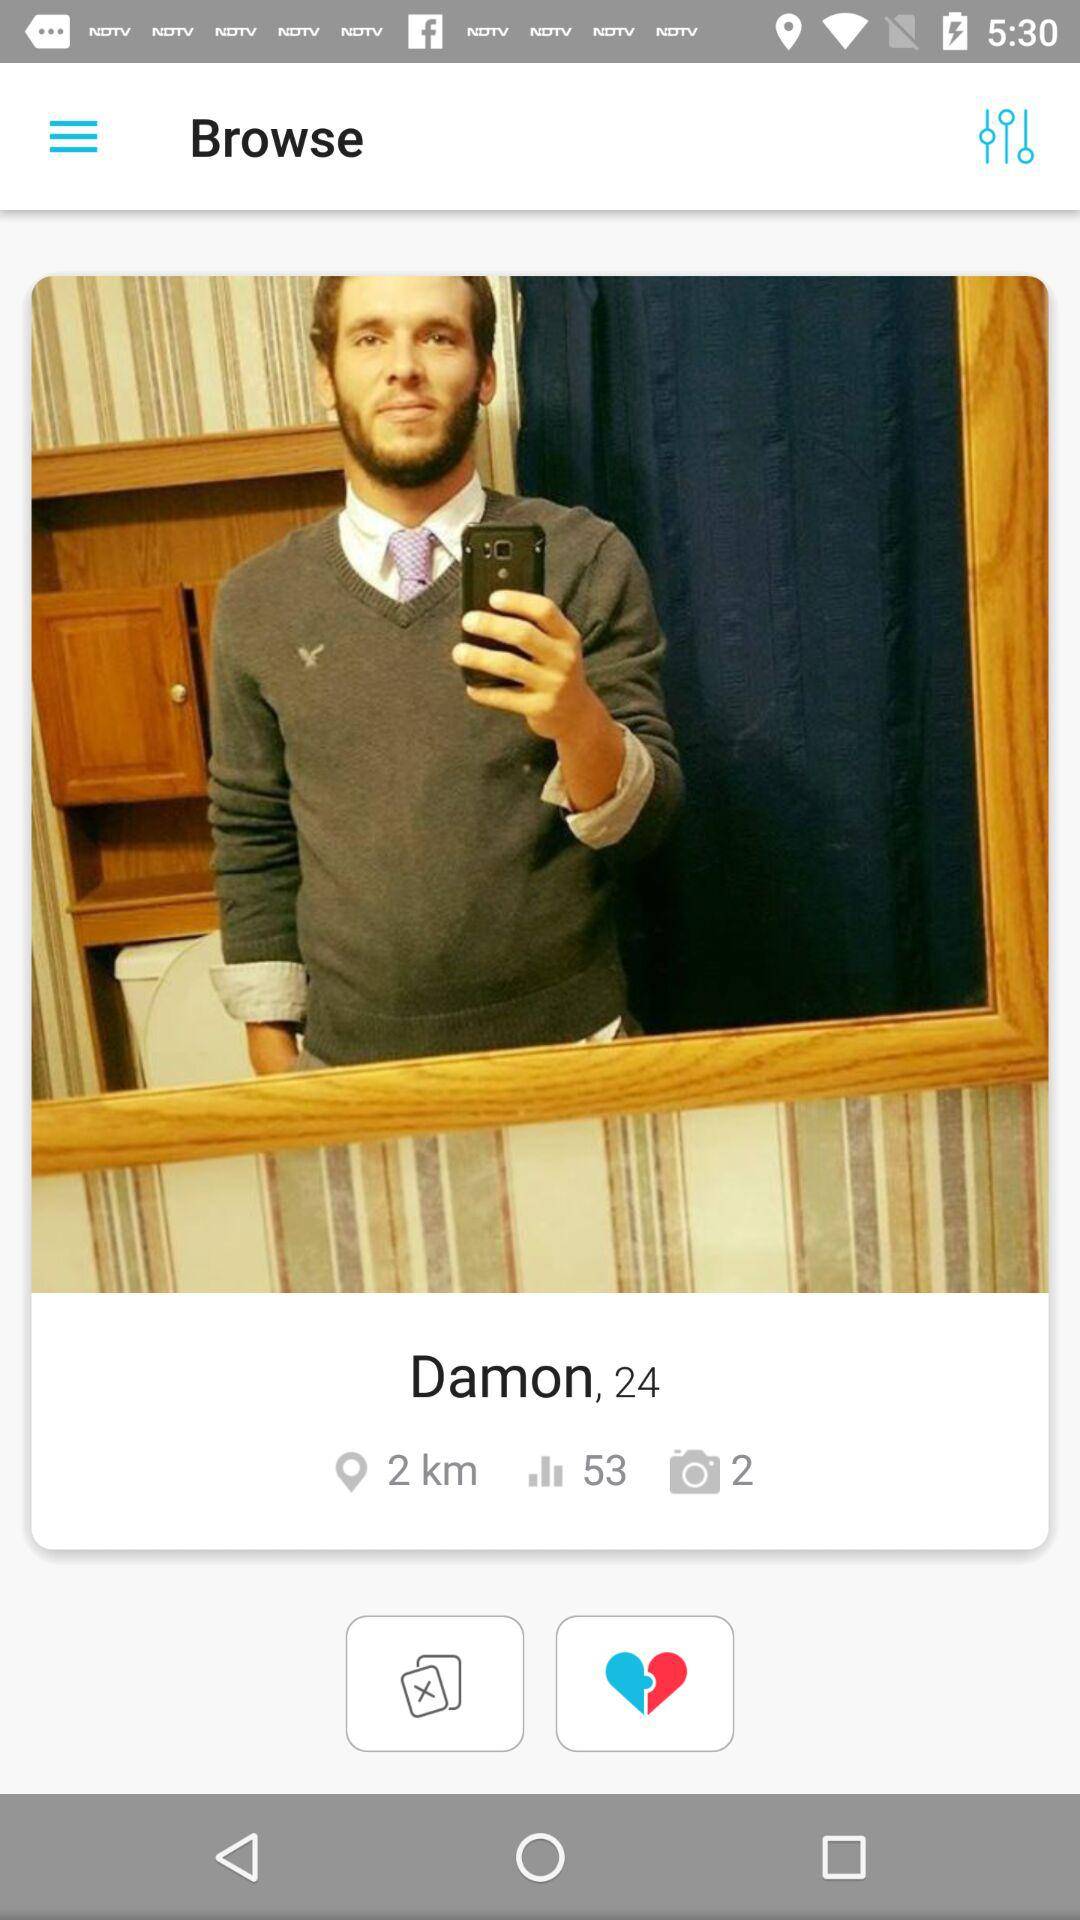How many images of Damon are there? Damon has 2 photos. 